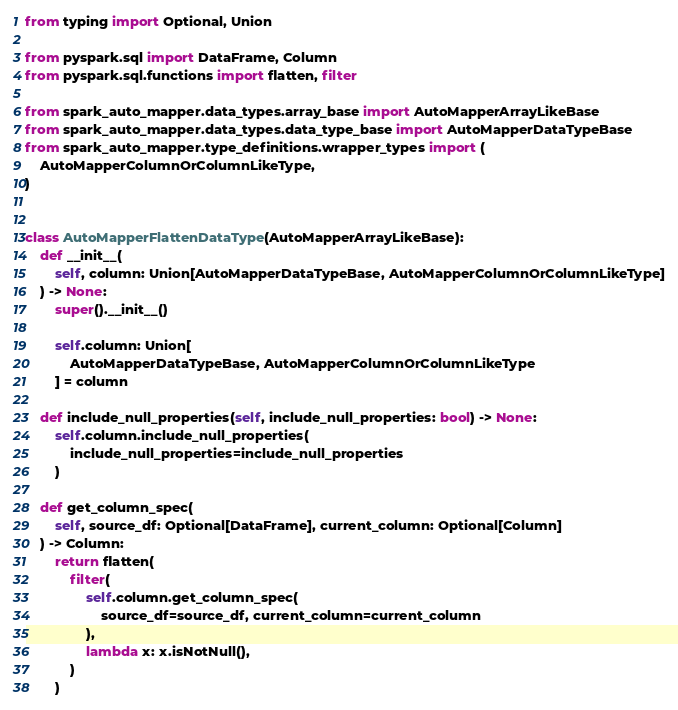Convert code to text. <code><loc_0><loc_0><loc_500><loc_500><_Python_>from typing import Optional, Union

from pyspark.sql import DataFrame, Column
from pyspark.sql.functions import flatten, filter

from spark_auto_mapper.data_types.array_base import AutoMapperArrayLikeBase
from spark_auto_mapper.data_types.data_type_base import AutoMapperDataTypeBase
from spark_auto_mapper.type_definitions.wrapper_types import (
    AutoMapperColumnOrColumnLikeType,
)


class AutoMapperFlattenDataType(AutoMapperArrayLikeBase):
    def __init__(
        self, column: Union[AutoMapperDataTypeBase, AutoMapperColumnOrColumnLikeType]
    ) -> None:
        super().__init__()

        self.column: Union[
            AutoMapperDataTypeBase, AutoMapperColumnOrColumnLikeType
        ] = column

    def include_null_properties(self, include_null_properties: bool) -> None:
        self.column.include_null_properties(
            include_null_properties=include_null_properties
        )

    def get_column_spec(
        self, source_df: Optional[DataFrame], current_column: Optional[Column]
    ) -> Column:
        return flatten(
            filter(
                self.column.get_column_spec(
                    source_df=source_df, current_column=current_column
                ),
                lambda x: x.isNotNull(),
            )
        )
</code> 